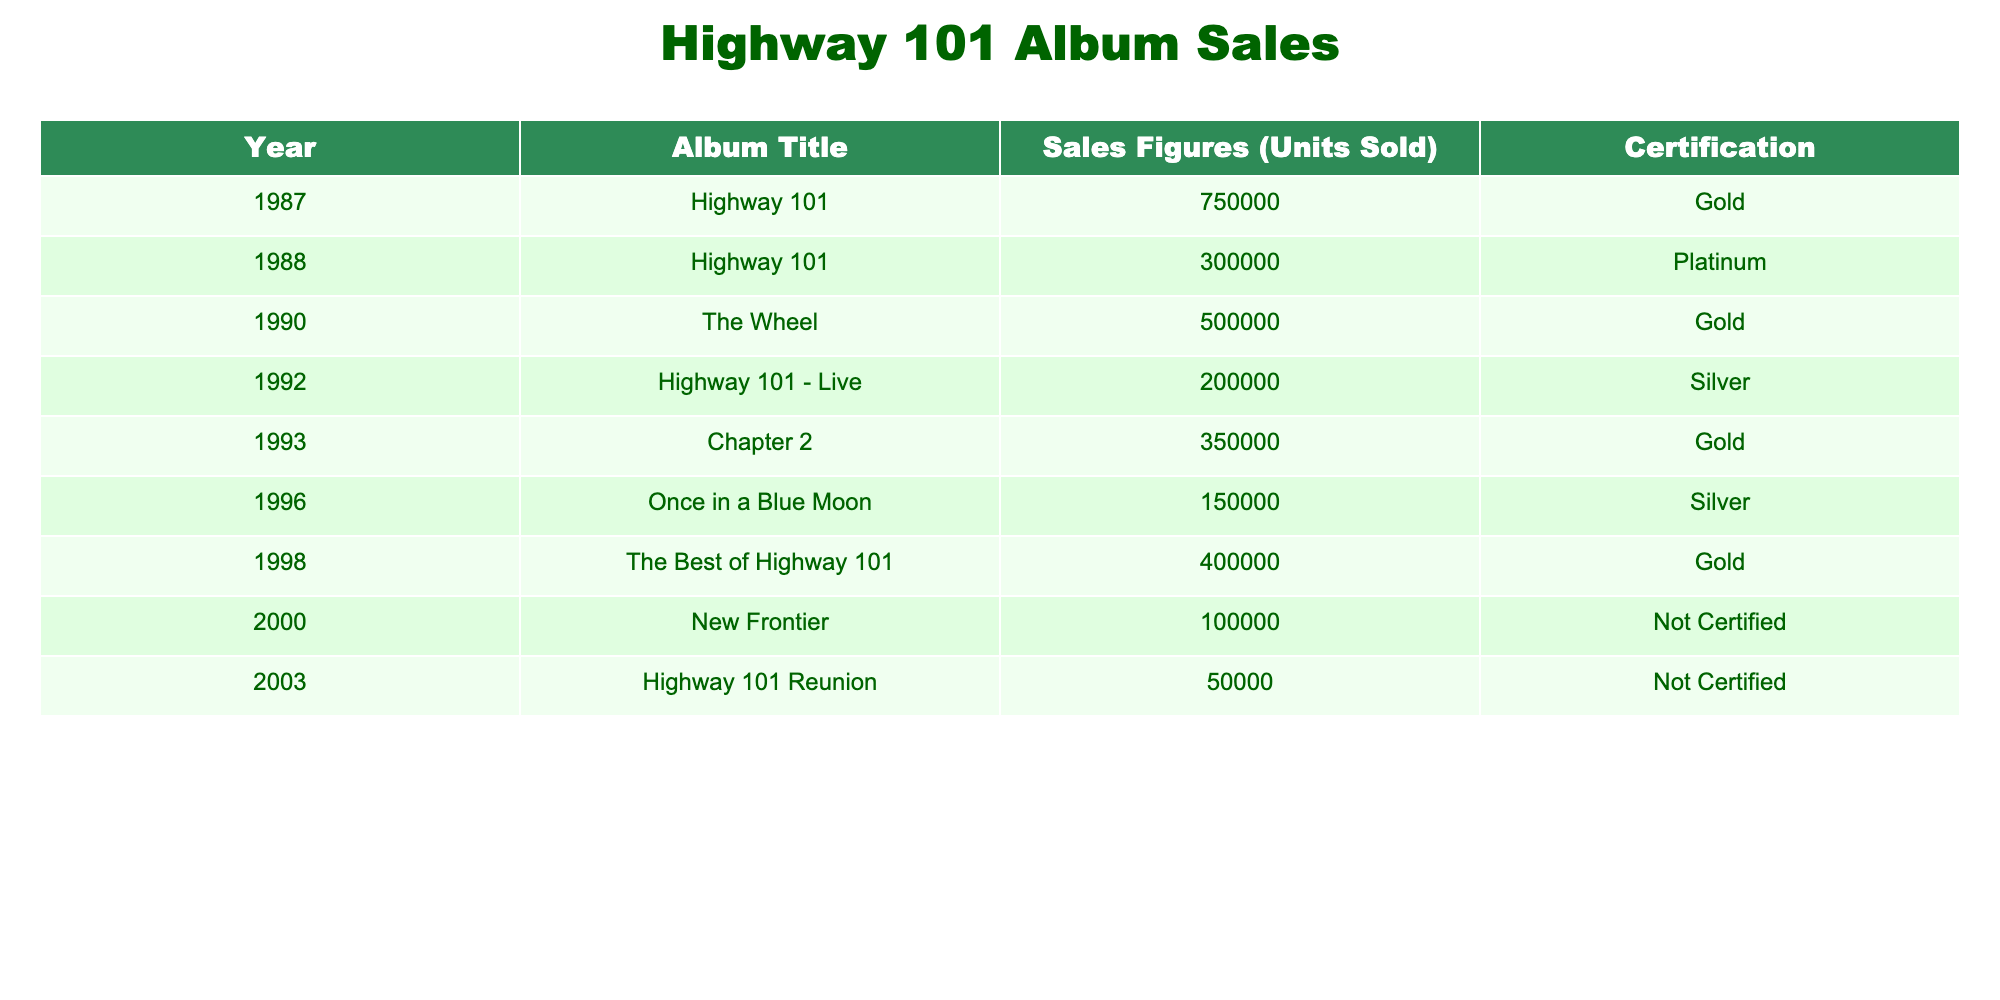What was the highest-selling album by Highway 101? The highest-selling album is "Highway 101," with sales figures of 750,000 units sold as noted in the table.
Answer: Highway 101 How many albums did Highway 101 release that achieved Gold certification? From the table, the albums that achieved Gold certification are: "Highway 101" (1987), "The Wheel" (1990), "Chapter 2" (1993), and "The Best of Highway 101" (1998), totaling four albums.
Answer: 4 What is the total number of units sold for all albums released in the 1990s? The albums released in the 1990s include "The Wheel" (500,000), "Highway 101 - Live" (200,000), "Chapter 2" (350,000), and "Once in a Blue Moon" (150,000). Their total sales figures add up to: 500,000 + 200,000 + 350,000 + 150,000 = 1,200,000 units.
Answer: 1200000 Did Highway 101 ever release an album that sold more than 300,000 units in the years after 2000? Looking at the sales figures for albums after 2000, "New Frontier" sold 100,000 units and "Highway 101 Reunion" sold 50,000 units. Both are below 300,000 units, so the answer is no.
Answer: No What was the average album sales figure for all Highway 101 albums? The total sales figures are calculated as follows: 750,000 + 300,000 + 500,000 + 200,000 + 350,000 + 150,000 + 400,000 + 100,000 + 50,000 = 2,900,000. There are 9 albums, so the average is 2,900,000 / 9 ≈ 322,222.22.
Answer: 322222.22 Which album had the lowest sales figure, and what was that figure? The album with the lowest sales figure is "Highway 101 Reunion," which sold only 50,000 units as indicated in the table.
Answer: Highway 101 Reunion, 50000 What percentage of the total sales comes from the album "Chapter 2"? The total sales are 2,900,000 units as calculated previously. "Chapter 2" sold 350,000 units. The percentage is calculated as (350,000 / 2,900,000) * 100 ≈ 12.07%.
Answer: 12.07% Was there any album released in the 1990s that achieved Silver certification? There is one album from the 1990s that achieved Silver certification, which is "Highway 101 - Live," released in 1992.
Answer: Yes 